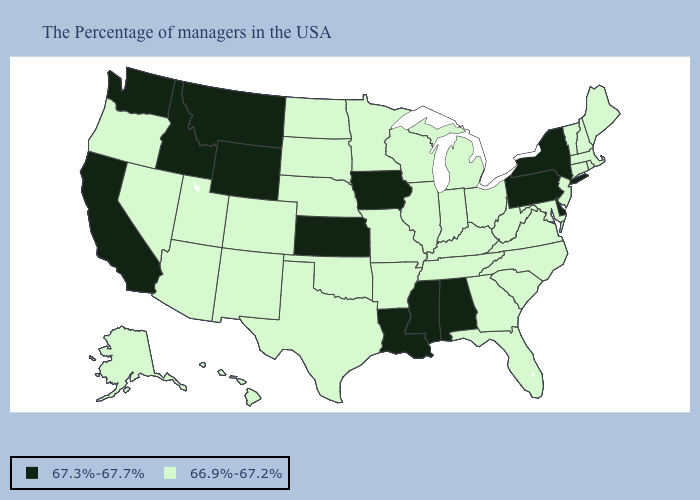What is the value of Wisconsin?
Be succinct. 66.9%-67.2%. Does California have the highest value in the West?
Keep it brief. Yes. What is the value of North Carolina?
Short answer required. 66.9%-67.2%. Among the states that border South Dakota , does Nebraska have the highest value?
Short answer required. No. What is the value of Utah?
Answer briefly. 66.9%-67.2%. Name the states that have a value in the range 66.9%-67.2%?
Answer briefly. Maine, Massachusetts, Rhode Island, New Hampshire, Vermont, Connecticut, New Jersey, Maryland, Virginia, North Carolina, South Carolina, West Virginia, Ohio, Florida, Georgia, Michigan, Kentucky, Indiana, Tennessee, Wisconsin, Illinois, Missouri, Arkansas, Minnesota, Nebraska, Oklahoma, Texas, South Dakota, North Dakota, Colorado, New Mexico, Utah, Arizona, Nevada, Oregon, Alaska, Hawaii. What is the value of Alaska?
Short answer required. 66.9%-67.2%. Which states have the highest value in the USA?
Answer briefly. New York, Delaware, Pennsylvania, Alabama, Mississippi, Louisiana, Iowa, Kansas, Wyoming, Montana, Idaho, California, Washington. What is the value of Georgia?
Answer briefly. 66.9%-67.2%. Does California have a lower value than Missouri?
Concise answer only. No. Does Delaware have a higher value than Iowa?
Quick response, please. No. What is the value of Delaware?
Answer briefly. 67.3%-67.7%. What is the lowest value in the USA?
Write a very short answer. 66.9%-67.2%. Name the states that have a value in the range 67.3%-67.7%?
Give a very brief answer. New York, Delaware, Pennsylvania, Alabama, Mississippi, Louisiana, Iowa, Kansas, Wyoming, Montana, Idaho, California, Washington. Among the states that border Illinois , does Iowa have the lowest value?
Answer briefly. No. 